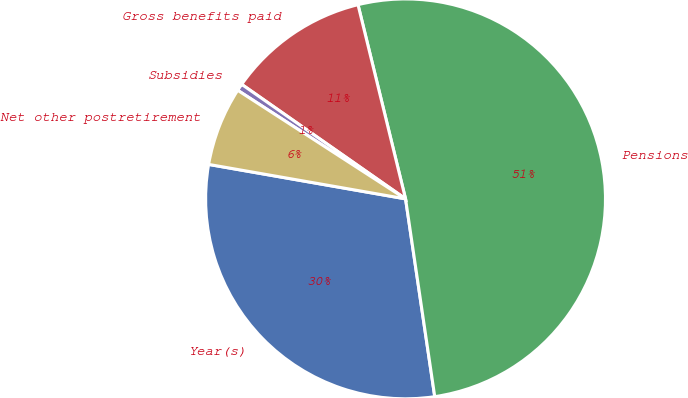Convert chart to OTSL. <chart><loc_0><loc_0><loc_500><loc_500><pie_chart><fcel>Year(s)<fcel>Pensions<fcel>Gross benefits paid<fcel>Subsidies<fcel>Net other postretirement<nl><fcel>30.09%<fcel>51.49%<fcel>11.47%<fcel>0.57%<fcel>6.38%<nl></chart> 